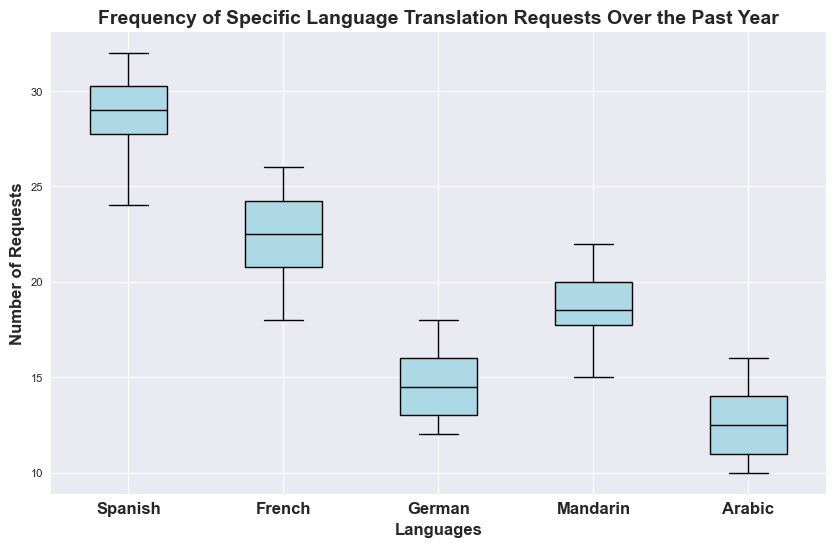Which language has the highest median frequency of translation requests? The box plot's median is indicated by the black line within each box. By comparing these lines, Spanish clearly has the highest median frequency.
Answer: Spanish What is the difference between the highest and lowest average translation requests among all languages? First, note the median values, which represent the average since the data seem symmetric. Spanish has the highest median, while Arabic has the lowest. The exact difference can be calculated by subtracting the median of Arabic from Spanish. For a detailed reason, the exact median values could be approximated visually.
Answer: ~18 Which language has the widest range of translation requests? The range is determined by the difference between the whiskers' endpoints. By visually comparing the overall spread of the whiskers, Arabic appears to have the widest range.
Answer: Arabic How often does the frequency of requests for Mandarin exceed 20? By observing the outliers (red dots), Mandarin exceeds 20 only a few times. Each outlier above 20 represents such an occurrence, and there seem to be a few instances.
Answer: Few times Are there any outliers in the French translation request data? Outliers in a box plot are indicated by red dots. French shows a couple of red dots above the box and whiskers.
Answer: Yes Which language shows the least variability in translation requests? Variability can be inferred from the interquartile range (IQR), represented by the length of the box. A smaller box means less variability. German’s box is significantly smaller than others.
Answer: German How does the median number of translation requests for Arabic compare with German? Reviewing the black median lines within each box, Arabic’s median line is slightly higher than German’s.
Answer: Arabic is higher What is the interquartile range (IQR) for French translation requests? IQR is the length of the box in a box plot. From the visual, approximate the upper boundary (Q3) and lower boundary (Q1) of the box for French and subtract Q1 from Q3.
Answer: ~4 Which months had a higher number of Spanish translation requests than the median value? Count the months where Spanish values exceed the black median line in the Spanish box. From the provided data, median approximates to months with requests above 28 for Spanish.
Answer: Feb, Apr, Aug, Sep, Oct Which language has its median translation requests closest to its upper quartile? The upper quartile (Q3) is the top edge of each box. Comparing the distance between the median (black line) and the top edges of the boxes, German’s median is closest to its Q3.
Answer: German 